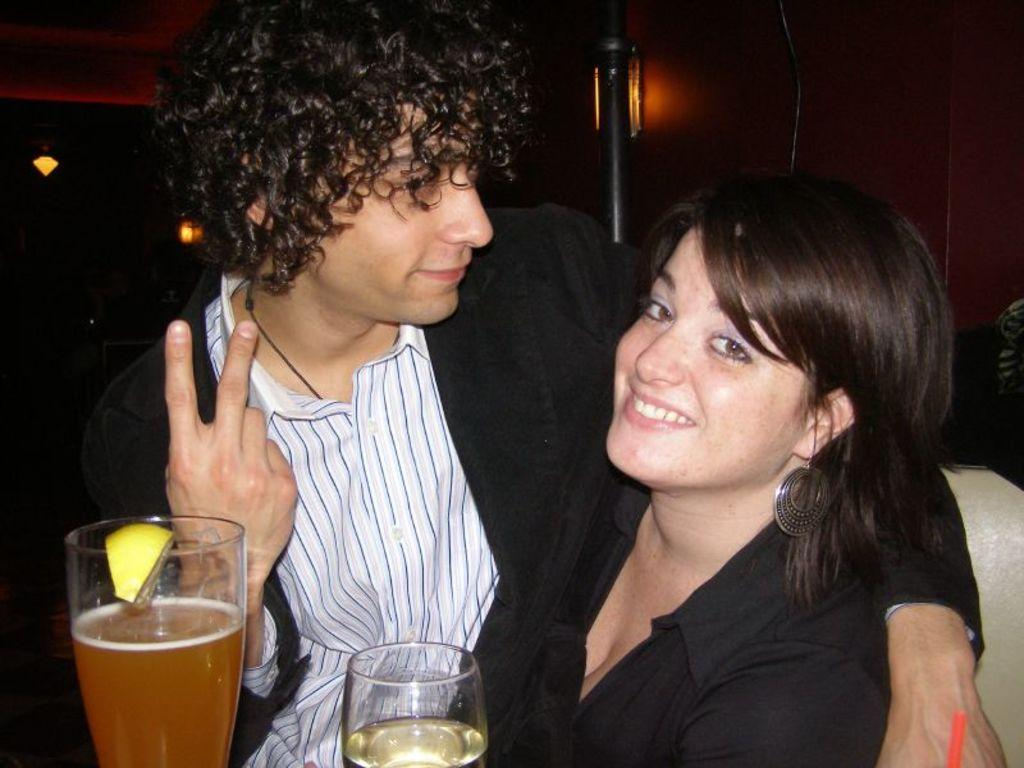How many people are present in the image? There is a man and a woman in the image. What objects can be seen in the image? There are glasses in the image, and one of the glasses has a lemon piece on it. What can be seen in the background of the image? There are lights visible in the background of the image. What type of engine is being used by the country in the image? There is no country or engine present in the image; it features a man, a woman, glasses, and lights in the background. Is there a spring visible in the image? No, there is no spring present in the image. 